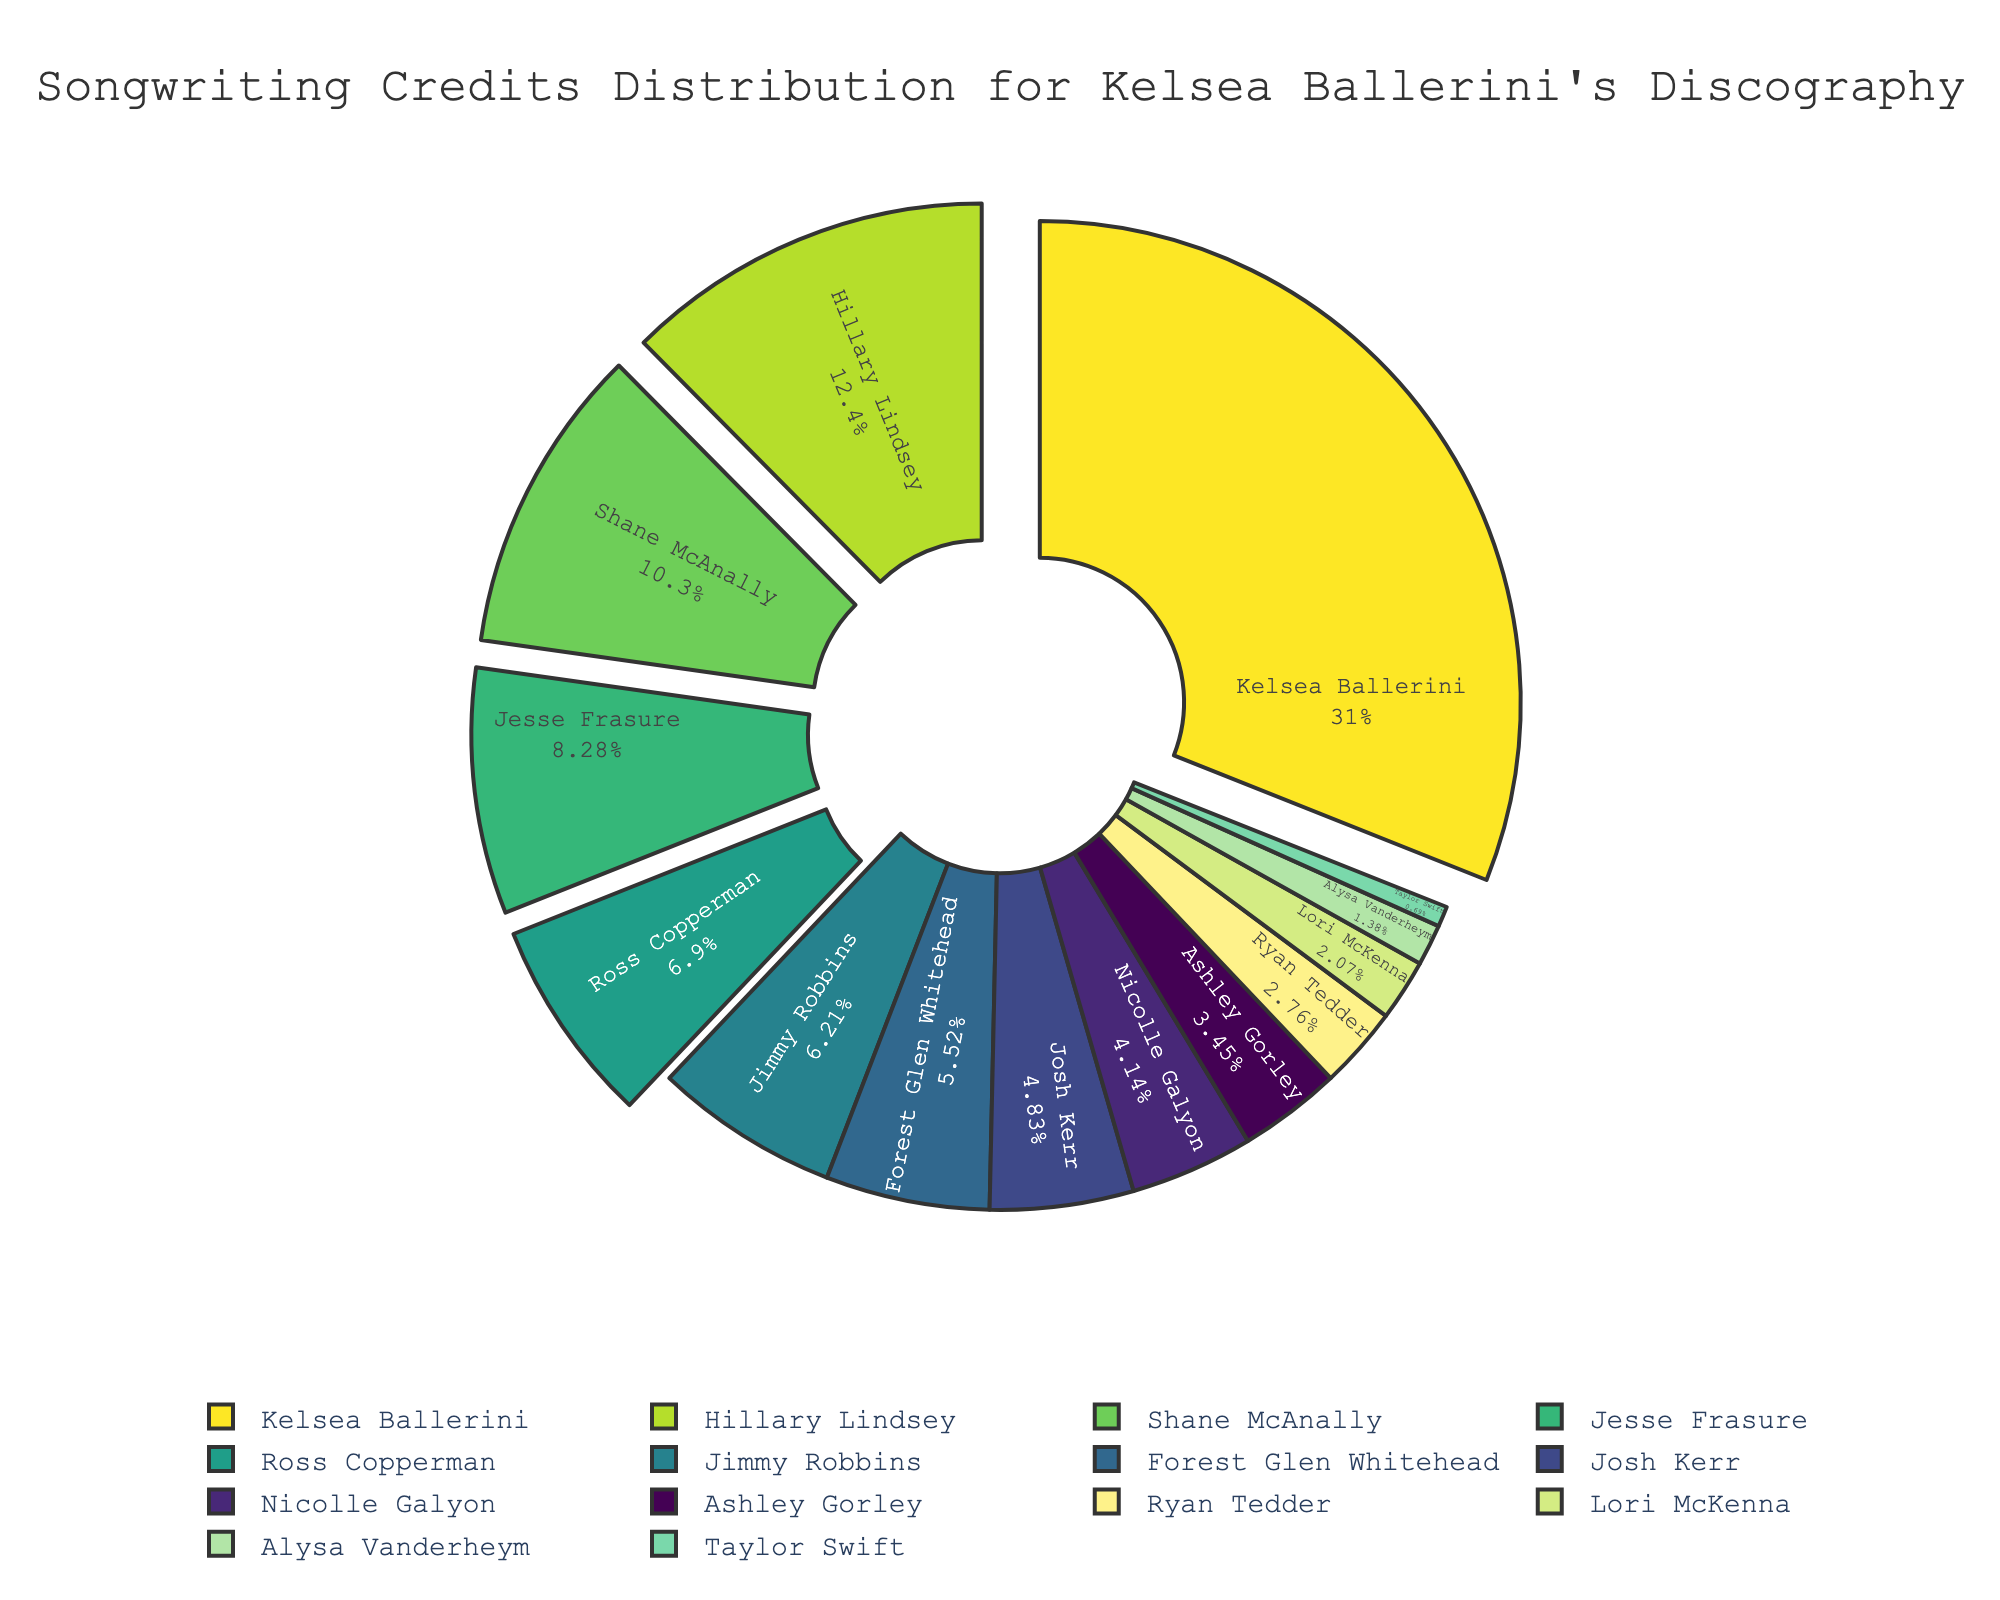what's the total number of songwriting credits? Sum the values for songwriting credits from all songwriters. The sum is 45 + 18 + 15 + 12 + 10 + 9 + 8 + 7 + 6 + 5 + 4 + 3 + 2 + 1 = 145
Answer: 145 Which songwriter has the highest number of credits? The largest segment representing the highest number of credits belongs to Kelsea Ballerini.
Answer: Kelsea Ballerini How many more credits does Kelsea Ballerini have compared to the second highest, Hillary Lindsey? Subtract Hillary Lindsey's credits (18) from Kelsea Ballerini’s credits (45). So, 45 - 18 = 27
Answer: 27 Which songwriters have fewer than 10 songwriting credits? Check segments representing songwriters with credits less than 10: Jimmy Robbins (9), Forest Glen Whitehead (8), Josh Kerr (7), Nicolle Galyon (6), Ashley Gorley (5), Ryan Tedder (4), Lori McKenna (3), Alysa Vanderheym (2), Taylor Swift (1)
Answer: Jimmy Robbins, Forest Glen Whitehead, Josh Kerr, Nicolle Galyon, Ashley Gorley, Ryan Tedder, Lori McKenna, Alysa Vanderheym, Taylor Swift What's the sum of songwriting credits for Nicolle Galyon, Ashley Gorley, and Ryan Tedder combined? Add the credits for Nicolle Galyon (6), Ashley Gorley (5), and Ryan Tedder (4). So, 6 + 5 + 4 = 15
Answer: 15 Is the total number of credits for Jesse Frasure and Ross Copperman equal to that of Shane McAnally? Add the credits for Jesse Frasure (12) and Ross Copperman (10), then compare with Shane McAnally's credits (15). 12 + 10 = 22, which is not equal to 15.
Answer: No Between Jimmy Robbins and Forest Glen Whitehead, who has more credits and by how many? Compare the credits: Jimmy Robbins (9) and Forest Glen Whitehead (8). Subtract 8 from 9: 9 - 8 = 1
Answer: Jimmy Robbins by 1 Does any songwriter have the same number of credits as Josh Kerr? No other songwriter has 7 songwriting credits, only Josh Kerr has 7.
Answer: No Which songwriter has exactly half the credits of Jesse Frasure? Check if any songwriter has credits equal to 12/2, i.e., 6. Nicolle Galyon has 6 credits which is exactly half of Jesse Frasure's 12.
Answer: Nicolle Galyon Are Alysa Vanderheym's and Taylor Swift's combined credits more than Lori McKenna's? Add Alysa Vanderheym’s (2) and Taylor Swift’s (1) credits; compare with Lori McKenna’s (3) credits: 2 + 1 = 3, which is equal to Lori McKenna’s credits.
Answer: No 